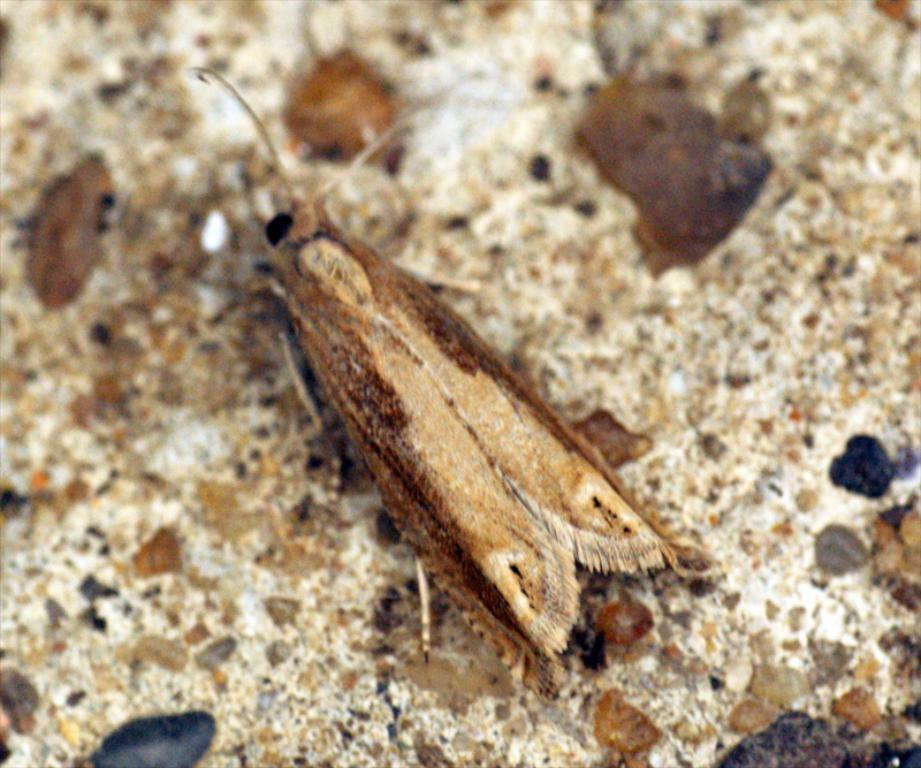What type of creature can be seen in the image? There is an insect in the image. Where is the insect located in the image? The insect is on a surface. What type of notebook is the insect writing on in the image? There is no notebook present in the image; it only features an insect on a surface. 